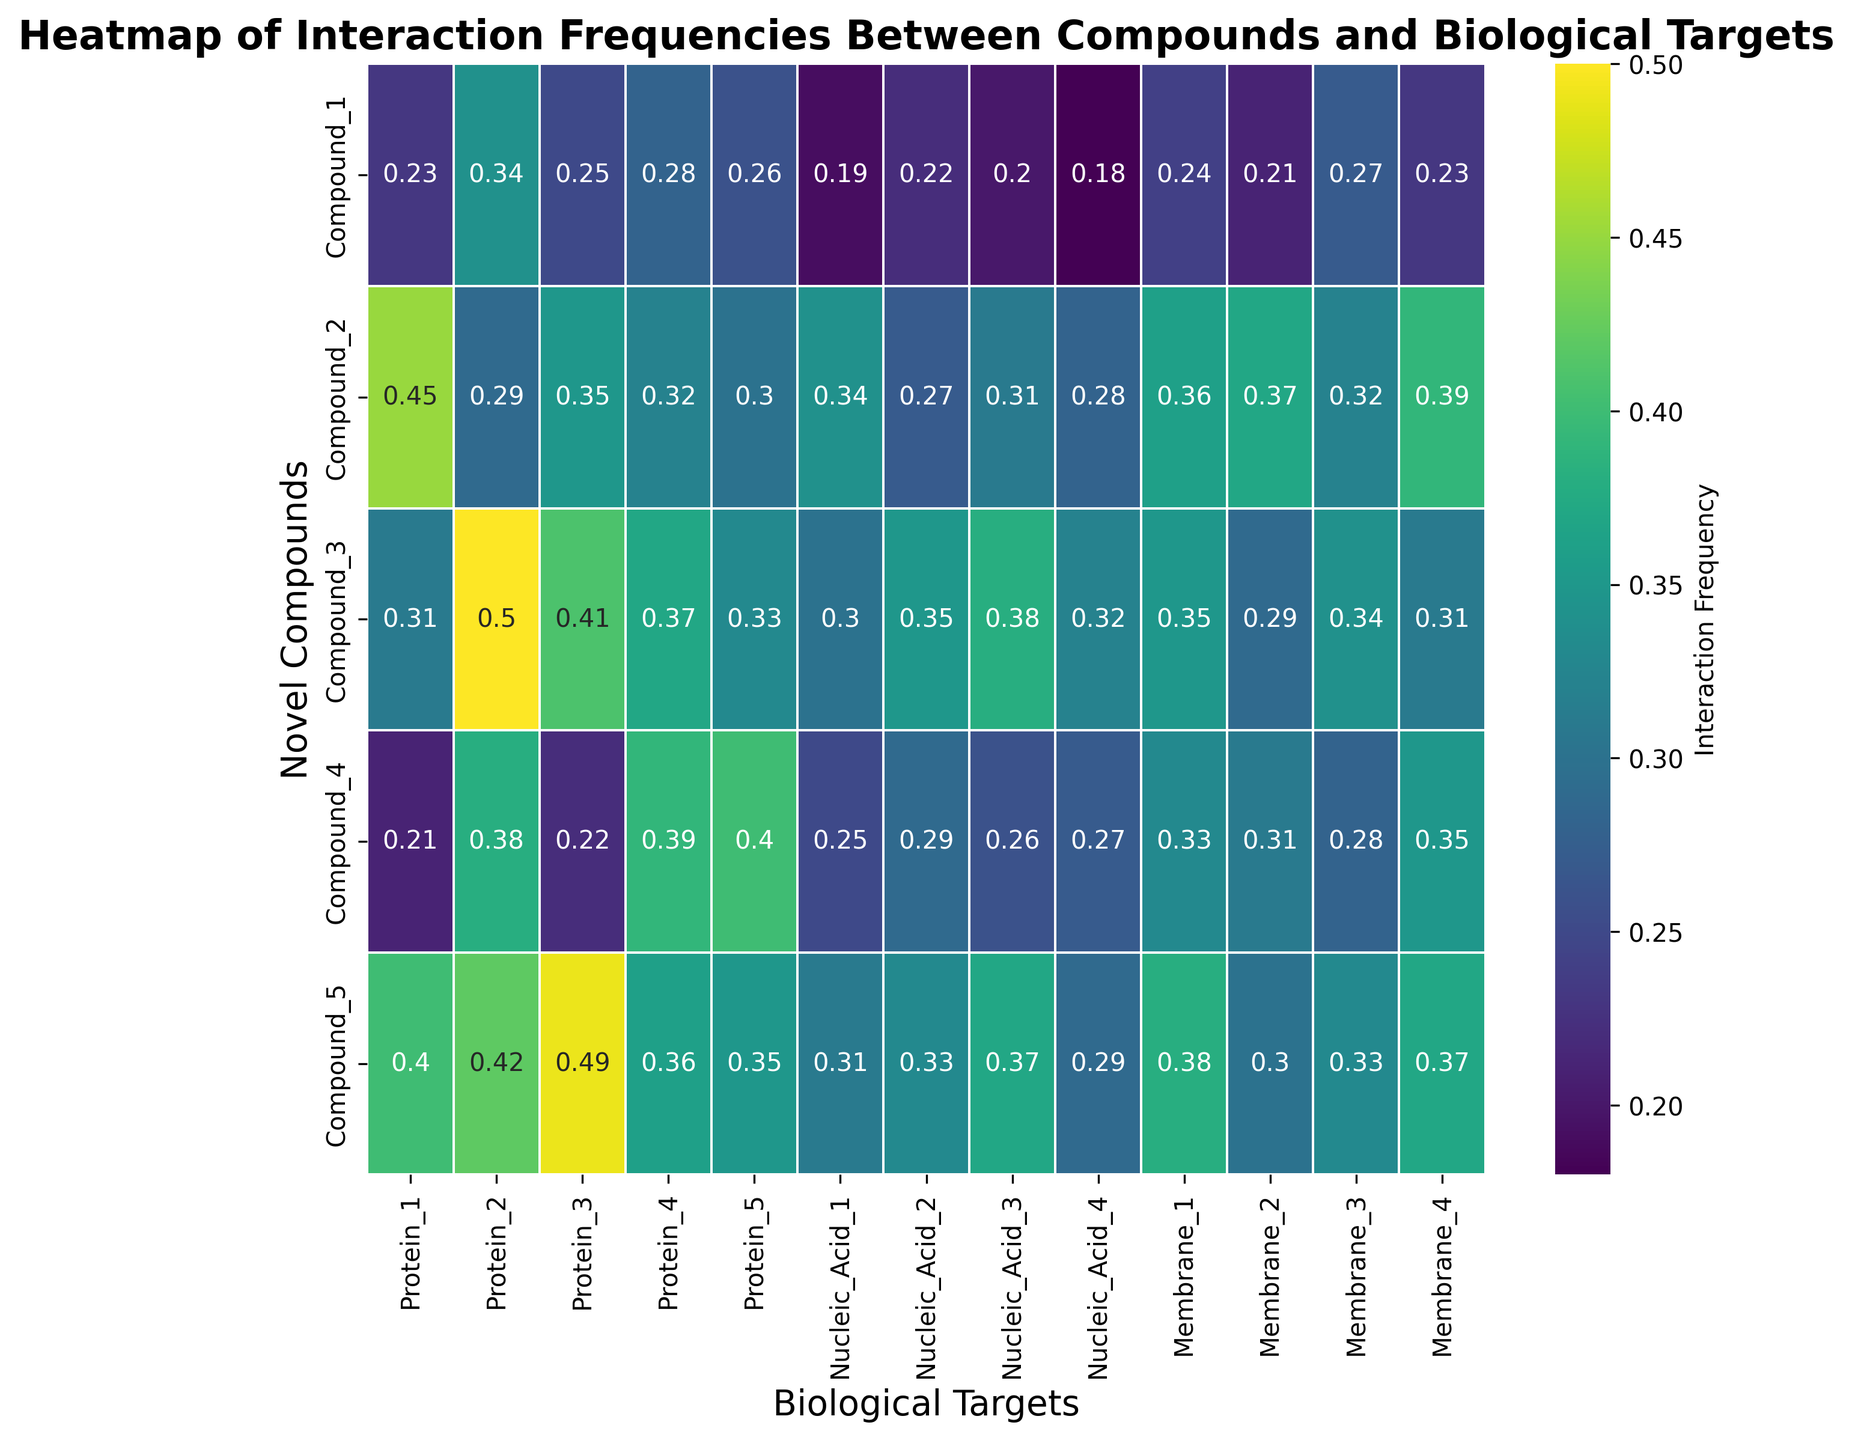What is the interaction frequency of Compound_3 with Protein_2? Find the cell where Compound_3 and Protein_2 intersect. The value in this cell represents the interaction frequency.
Answer: 0.50 Which compound has the highest interaction frequency with Nucleic_Acid_3? Locate the row labeled Nucleic_Acid_3 and identify the highest value within this row. The corresponding column header represents the compound.
Answer: Compound_3 Which biological target does Compound_1 interact with the least? Scan the row for Compound_1 and detect the smallest value. The corresponding row header is the target.
Answer: Nucleic_Acid_4 What is the average interaction frequency of Compound_4 across all biological targets? Sum all the interaction frequencies of Compound_4 and then divide by the number of targets (14 in this case). Calculate as (0.21 + 0.38 + 0.22 + 0.39 + 0.40 + 0.25 + 0.29 + 0.26 + 0.27 + 0.33 + 0.31 + 0.28 + 0.35) / 14.
Answer: 0.30 Compare the interaction frequency of Compound_2 with Membrane_1 and Membrane_2. Which one is higher? Identify the values in the row Membrane_1 and Membrane_2 for Compound_2. Compare these two values to see which one is larger.
Answer: Membrane_2 What is the range of interaction frequencies for Protein_3? Find the maximum and minimum frequencies in the row for Protein_3. The range is the difference between these two values.
Answer: 0.27 In which target, Compound_5 has the highest interaction frequency, and what is this frequency? Look for the highest value in the row for Compound_5. The corresponding target signifies where this interaction occurs.
Answer: Protein_3, 0.49 How do the average interaction frequencies of all compounds with Protein_1 and Protein_4 compare? Calculate the average for Protein_1 (sum of values over the number of compounds) and similarly for Protein_4. Compare these two averages.
Answer: Protein_4 has a higher average 